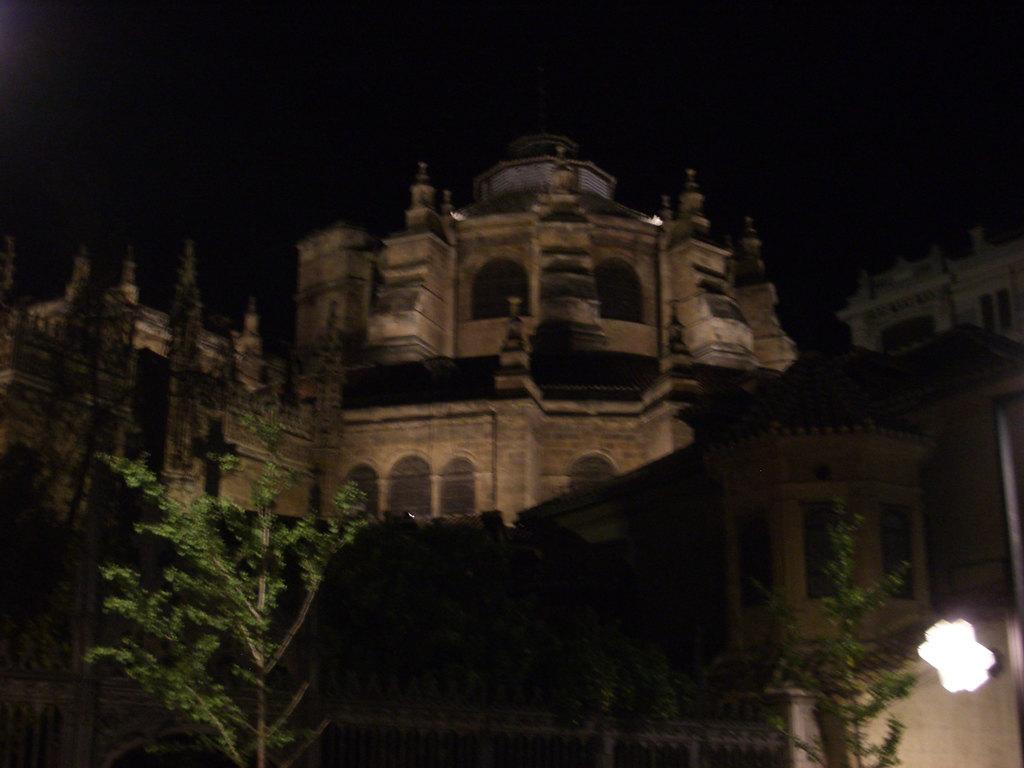What structure is located at the top of the image? There is a building at the top of the image. What type of vegetation can be seen in the middle of the image? There are trees in the middle of the image. What type of entrance is visible at the bottom of the image? There is a fencing gate at the bottom of the image. Can you see any rats or jellyfish in the image? No, there are no rats or jellyfish present in the image. What type of bird can be seen flying over the trees in the image? There is no bird visible in the image; it only features a building, trees, and a fencing gate. 